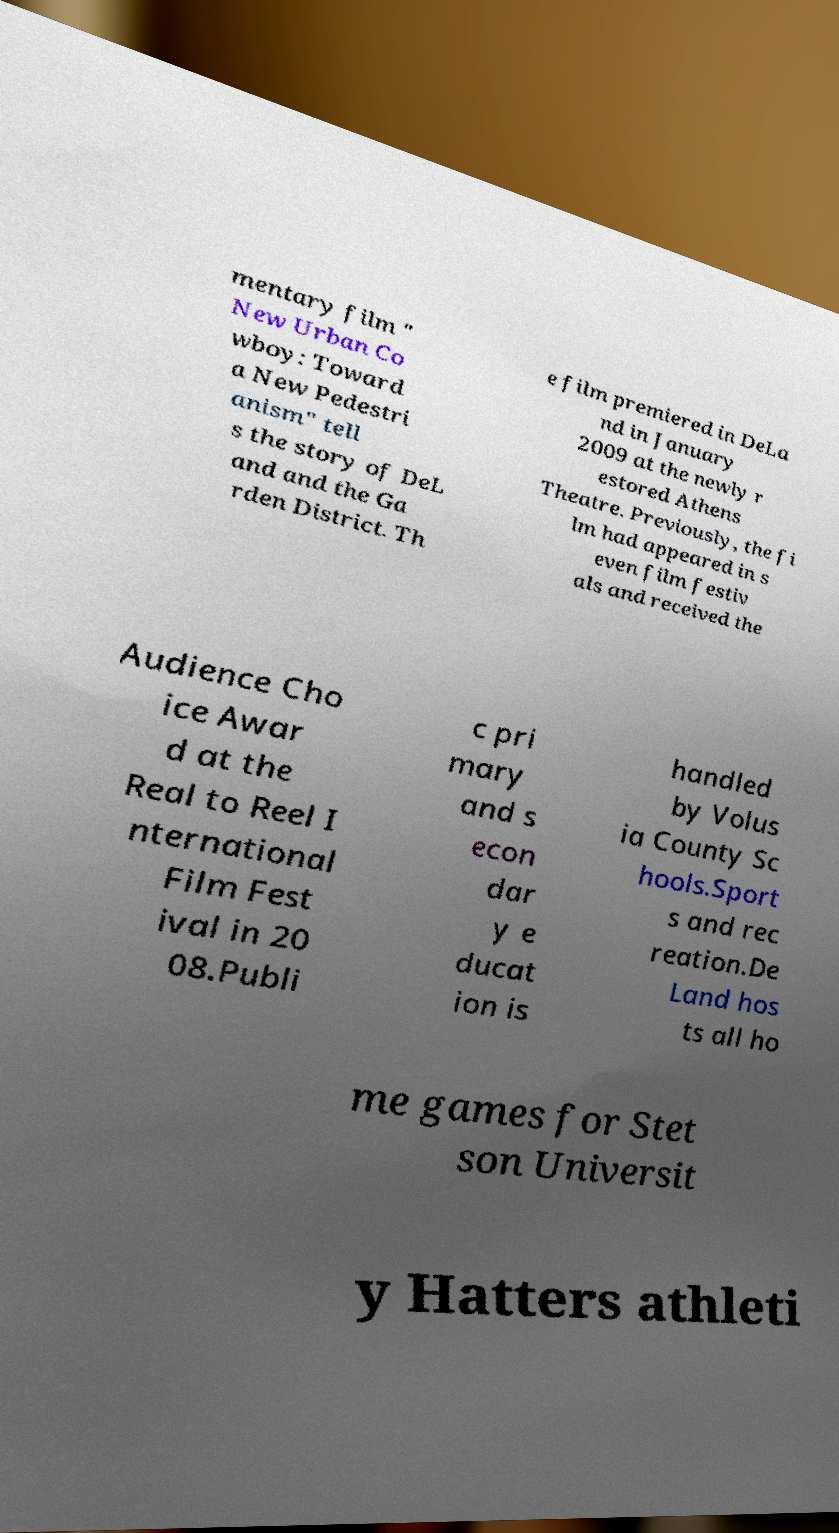I need the written content from this picture converted into text. Can you do that? mentary film " New Urban Co wboy: Toward a New Pedestri anism" tell s the story of DeL and and the Ga rden District. Th e film premiered in DeLa nd in January 2009 at the newly r estored Athens Theatre. Previously, the fi lm had appeared in s even film festiv als and received the Audience Cho ice Awar d at the Real to Reel I nternational Film Fest ival in 20 08.Publi c pri mary and s econ dar y e ducat ion is handled by Volus ia County Sc hools.Sport s and rec reation.De Land hos ts all ho me games for Stet son Universit y Hatters athleti 